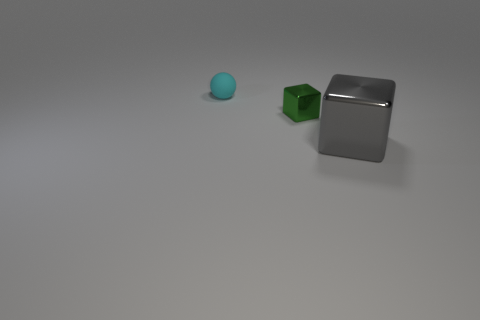The thing on the left side of the shiny thing that is to the left of the large metallic block is what shape?
Give a very brief answer. Sphere. How many large things are red metallic things or balls?
Your answer should be very brief. 0. How many other small green metallic objects have the same shape as the green thing?
Offer a terse response. 0. Is the shape of the tiny shiny thing the same as the metallic thing that is right of the small metal cube?
Give a very brief answer. Yes. How many objects are in front of the small cyan rubber thing?
Give a very brief answer. 2. Are there any blue metallic cylinders of the same size as the cyan matte object?
Make the answer very short. No. Do the small thing in front of the cyan sphere and the big object have the same shape?
Offer a very short reply. Yes. What color is the tiny shiny object?
Make the answer very short. Green. Is there a large purple matte object?
Offer a terse response. No. What size is the block that is the same material as the green thing?
Provide a succinct answer. Large. 